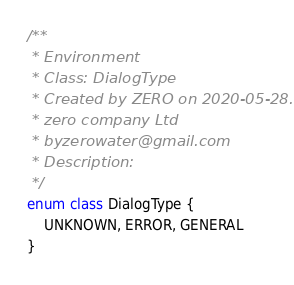Convert code to text. <code><loc_0><loc_0><loc_500><loc_500><_Kotlin_>
/**
 * Environment
 * Class: DialogType
 * Created by ZERO on 2020-05-28.
 * zero company Ltd
 * byzerowater@gmail.com
 * Description:
 */
enum class DialogType {
    UNKNOWN, ERROR, GENERAL
}</code> 